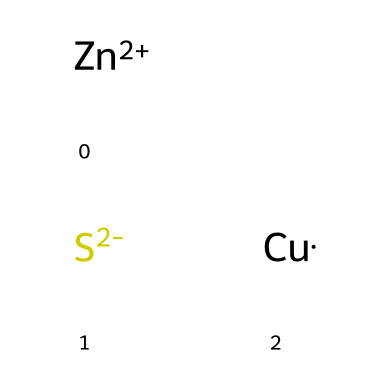What is the charge of zinc in this chemical? The SMILES notation indicates that zinc is represented as [Zn+2], which signifies a +2 charge.
Answer: +2 How many different elements are present in this chemical? By analyzing the SMILES representation, we can identify three distinct elements: zinc (Zn), sulfur (S), and copper (Cu).
Answer: 3 What role does sulfur play in this chemical structure? The presence of [S-2] indicates that sulfur is in a -2 oxidation state, suggesting it likely acts as a counterion to balance the positive charge of zinc.
Answer: Counterion Is this compound likely to exhibit photoluminescent properties? Yes, the presence of transition metals like zinc and copper often contributes to photoluminescent effects, making this compound a candidate for such properties.
Answer: Yes What type of bonding is suggested between the elements in this chemical? The notation shows that the elements have both positive and negative charges, suggesting ionic bonding, particularly between zinc and sulfur.
Answer: Ionic What coordinate number might zinc have in this chemical? Zinc often has a coordination number of 4 in complex compounds, though this can vary based on ligands; here, its role may contribute to maintaining the structure with its +2 state.
Answer: 4 How does the composition of this paint affect its reflectivity at night? The presence of photoreactive agents like copper and zinc contributes to reflectivity under certain light conditions, enhancing visibility at night.
Answer: Enhances visibility 